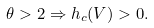<formula> <loc_0><loc_0><loc_500><loc_500>\theta > 2 \Rightarrow h _ { c } ( V ) > 0 .</formula> 